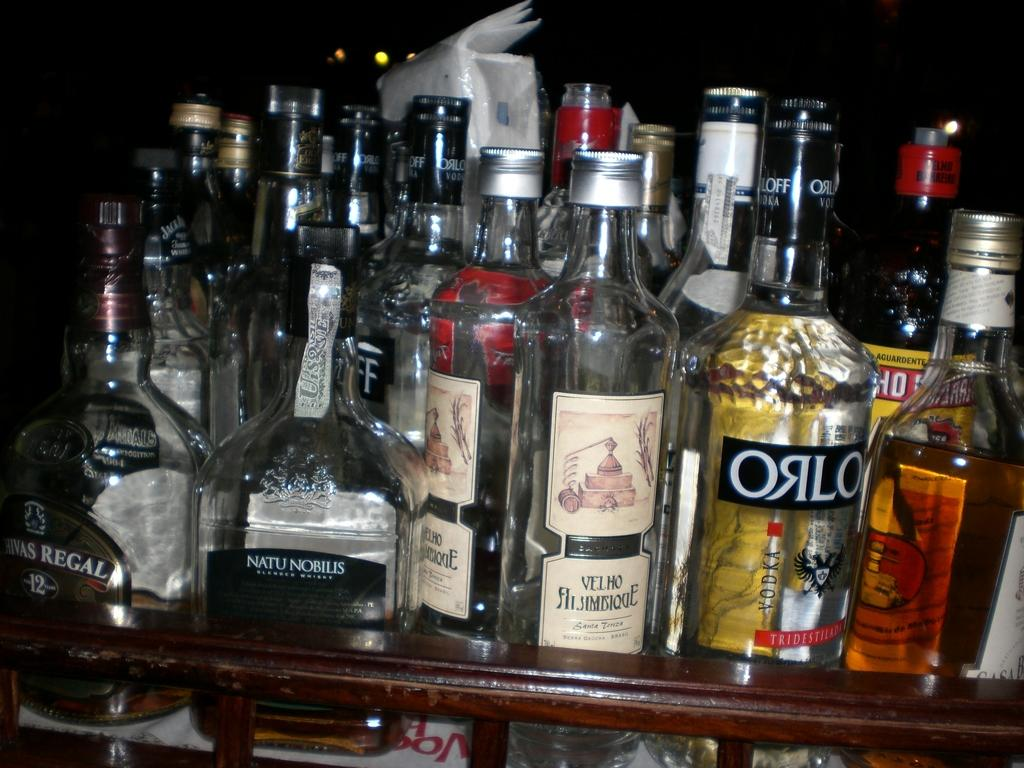<image>
Offer a succinct explanation of the picture presented. the word orlo that is on a wine bottle 